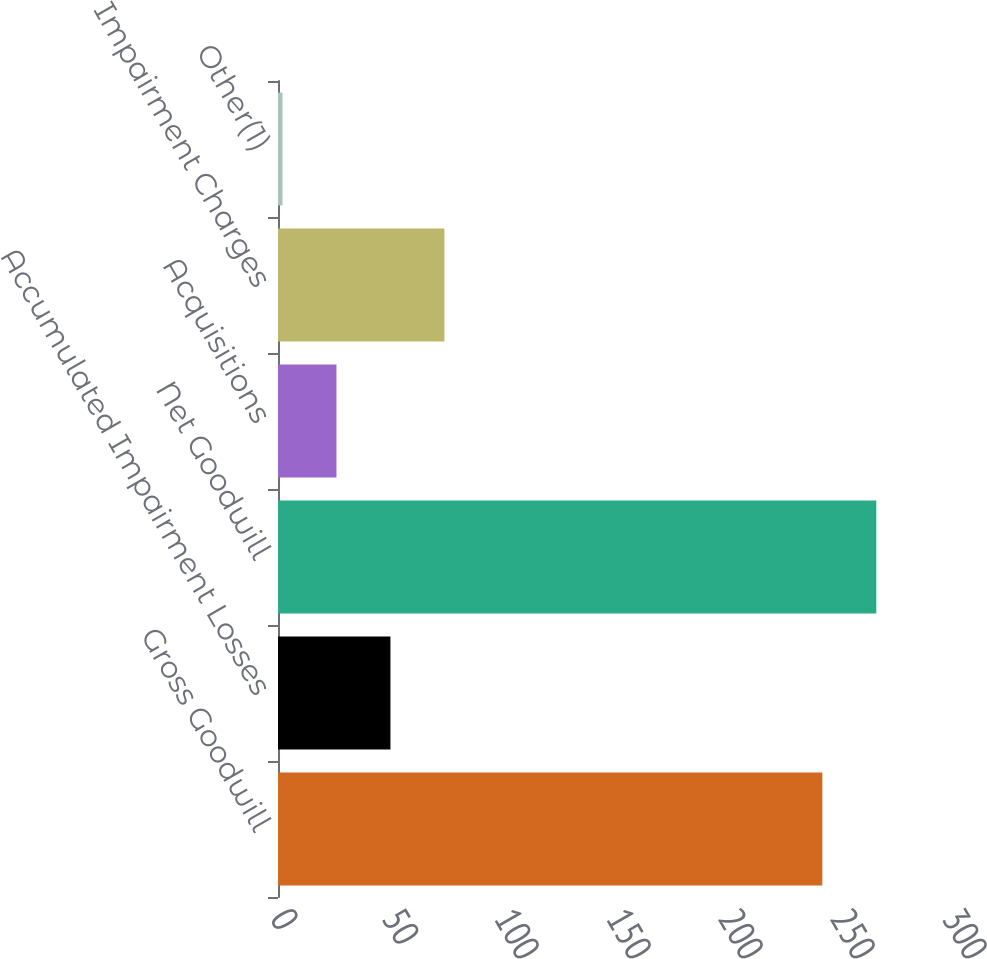<chart> <loc_0><loc_0><loc_500><loc_500><bar_chart><fcel>Gross Goodwill<fcel>Accumulated Impairment Losses<fcel>Net Goodwill<fcel>Acquisitions<fcel>Impairment Charges<fcel>Other(1)<nl><fcel>243<fcel>50.2<fcel>267.1<fcel>26.1<fcel>74.3<fcel>2<nl></chart> 